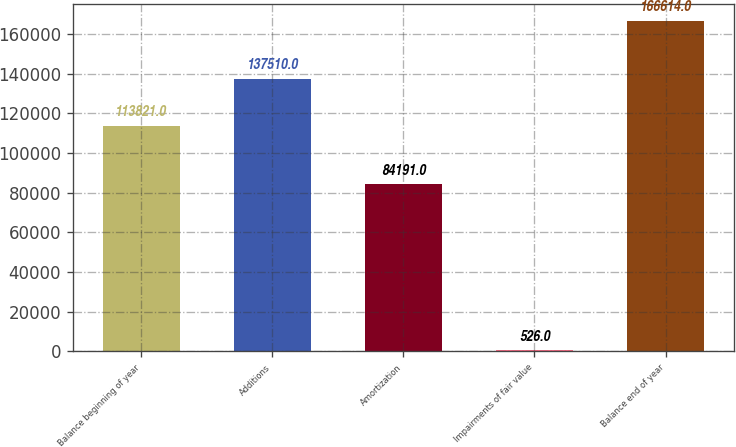<chart> <loc_0><loc_0><loc_500><loc_500><bar_chart><fcel>Balance beginning of year<fcel>Additions<fcel>Amortization<fcel>Impairments of fair value<fcel>Balance end of year<nl><fcel>113821<fcel>137510<fcel>84191<fcel>526<fcel>166614<nl></chart> 